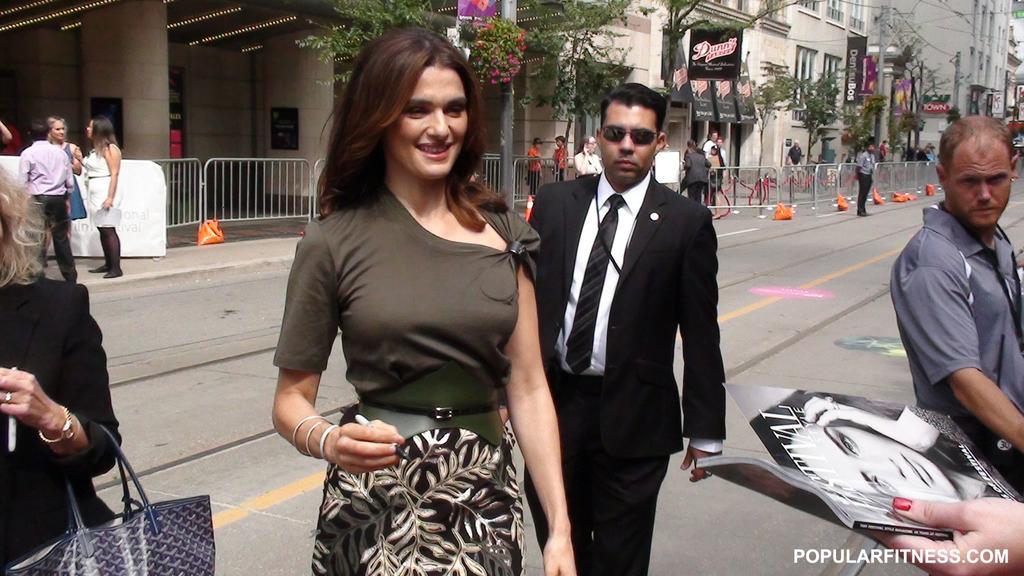Please provide a concise description of this image. This image is taken outdoors. In the background there are many buildings with walls, windows and doors. There are a few trees and there are a few boards with text on them. There are a few railings and there are a few objects on the road. A few people are walking on the road and a few are standing. On the left side of the image two women and a man are standing on the sidewalk. There is another woman and she is holding a handbag in her hand. In the middle of the image a man and a woman are walking on the road. A woman is with a smiling face. On the right side of the image there is a man and there is a person's hand holding a book in the hand. 